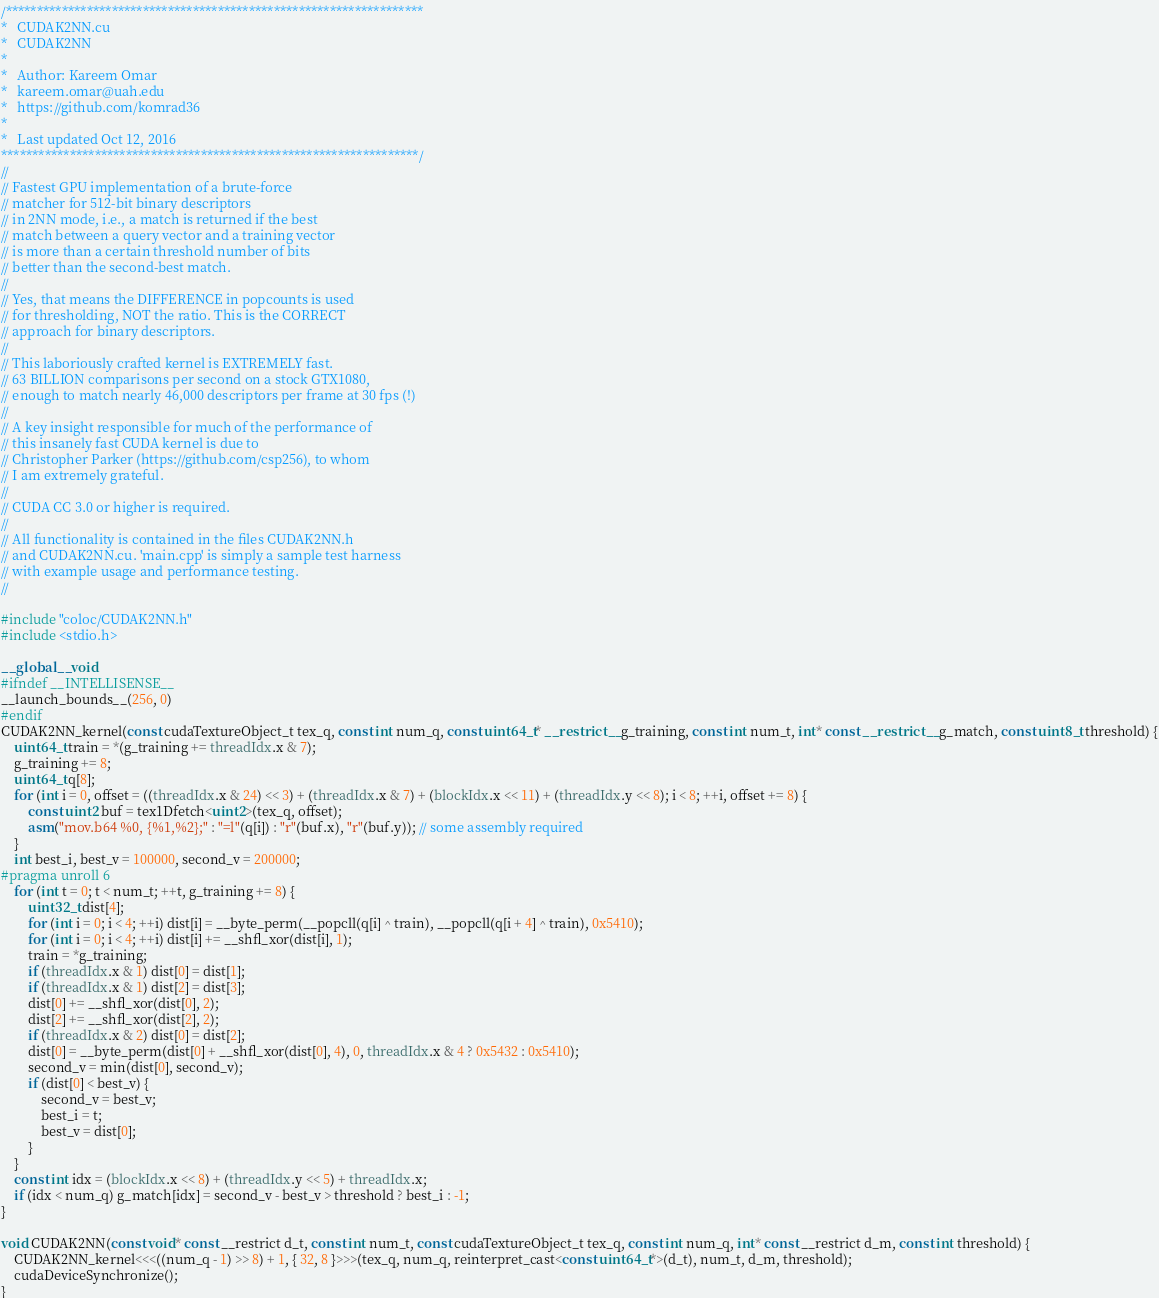Convert code to text. <code><loc_0><loc_0><loc_500><loc_500><_Cuda_>/*******************************************************************
*   CUDAK2NN.cu
*   CUDAK2NN
*
*	Author: Kareem Omar
*	kareem.omar@uah.edu
*	https://github.com/komrad36
*
*	Last updated Oct 12, 2016
*******************************************************************/
//
// Fastest GPU implementation of a brute-force
// matcher for 512-bit binary descriptors
// in 2NN mode, i.e., a match is returned if the best
// match between a query vector and a training vector
// is more than a certain threshold number of bits
// better than the second-best match.
//
// Yes, that means the DIFFERENCE in popcounts is used
// for thresholding, NOT the ratio. This is the CORRECT
// approach for binary descriptors.
//
// This laboriously crafted kernel is EXTREMELY fast.
// 63 BILLION comparisons per second on a stock GTX1080,
// enough to match nearly 46,000 descriptors per frame at 30 fps (!)
//
// A key insight responsible for much of the performance of
// this insanely fast CUDA kernel is due to
// Christopher Parker (https://github.com/csp256), to whom
// I am extremely grateful.
//
// CUDA CC 3.0 or higher is required.
//
// All functionality is contained in the files CUDAK2NN.h
// and CUDAK2NN.cu. 'main.cpp' is simply a sample test harness
// with example usage and performance testing.
//

#include "coloc/CUDAK2NN.h"
#include <stdio.h>

__global__ void
#ifndef __INTELLISENSE__
__launch_bounds__(256, 0)
#endif
CUDAK2NN_kernel(const cudaTextureObject_t tex_q, const int num_q, const uint64_t* __restrict__ g_training, const int num_t, int* const __restrict__ g_match, const uint8_t threshold) {
	uint64_t train = *(g_training += threadIdx.x & 7);
	g_training += 8;
	uint64_t q[8];
	for (int i = 0, offset = ((threadIdx.x & 24) << 3) + (threadIdx.x & 7) + (blockIdx.x << 11) + (threadIdx.y << 8); i < 8; ++i, offset += 8) {
		const uint2 buf = tex1Dfetch<uint2>(tex_q, offset);
		asm("mov.b64 %0, {%1,%2};" : "=l"(q[i]) : "r"(buf.x), "r"(buf.y)); // some assembly required
	}	
	int best_i, best_v = 100000, second_v = 200000;
#pragma unroll 6
	for (int t = 0; t < num_t; ++t, g_training += 8) {
		uint32_t dist[4];
		for (int i = 0; i < 4; ++i) dist[i] = __byte_perm(__popcll(q[i] ^ train), __popcll(q[i + 4] ^ train), 0x5410);
		for (int i = 0; i < 4; ++i) dist[i] += __shfl_xor(dist[i], 1);
		train = *g_training;
		if (threadIdx.x & 1) dist[0] = dist[1];
		if (threadIdx.x & 1) dist[2] = dist[3];
		dist[0] += __shfl_xor(dist[0], 2);
		dist[2] += __shfl_xor(dist[2], 2);
		if (threadIdx.x & 2) dist[0] = dist[2];
		dist[0] = __byte_perm(dist[0] + __shfl_xor(dist[0], 4), 0, threadIdx.x & 4 ? 0x5432 : 0x5410);
		second_v = min(dist[0], second_v);
		if (dist[0] < best_v) {
			second_v = best_v;
			best_i = t;
			best_v = dist[0];
		}
	}
	const int idx = (blockIdx.x << 8) + (threadIdx.y << 5) + threadIdx.x;
	if (idx < num_q) g_match[idx] = second_v - best_v > threshold ? best_i : -1;
}

void CUDAK2NN(const void* const __restrict d_t, const int num_t, const cudaTextureObject_t tex_q, const int num_q, int* const __restrict d_m, const int threshold) {
	CUDAK2NN_kernel<<<((num_q - 1) >> 8) + 1, { 32, 8 }>>>(tex_q, num_q, reinterpret_cast<const uint64_t*>(d_t), num_t, d_m, threshold);
	cudaDeviceSynchronize();
}
</code> 